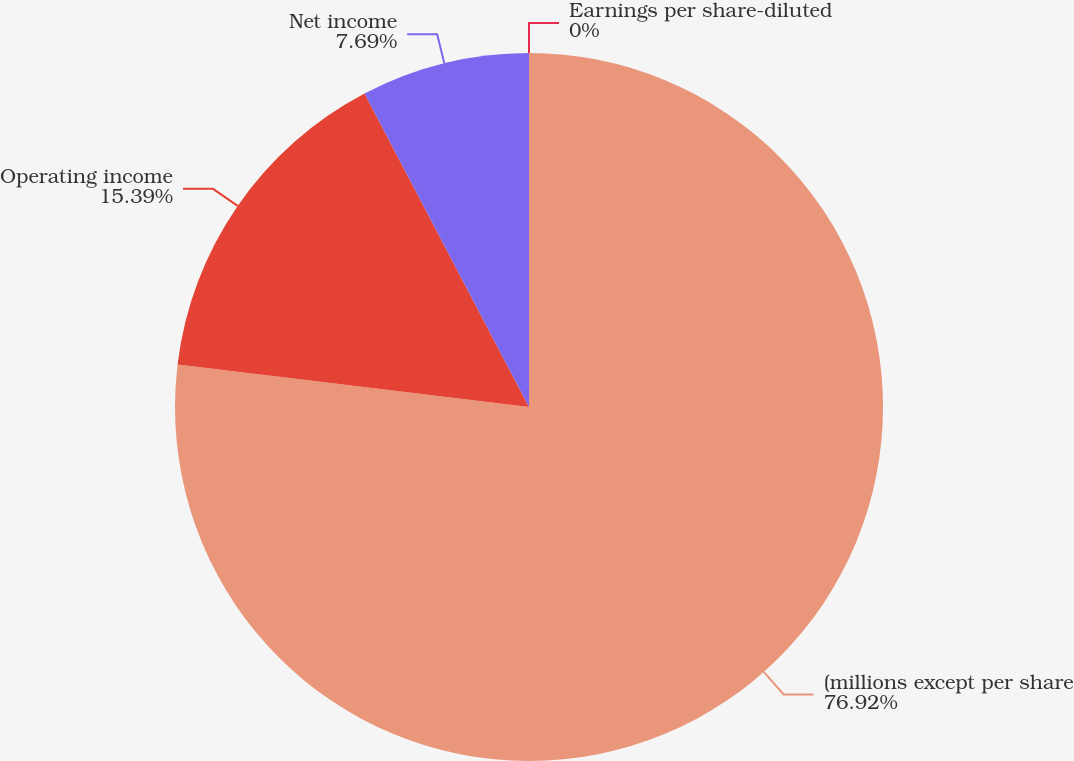<chart> <loc_0><loc_0><loc_500><loc_500><pie_chart><fcel>(millions except per share<fcel>Operating income<fcel>Net income<fcel>Earnings per share-diluted<nl><fcel>76.92%<fcel>15.39%<fcel>7.69%<fcel>0.0%<nl></chart> 